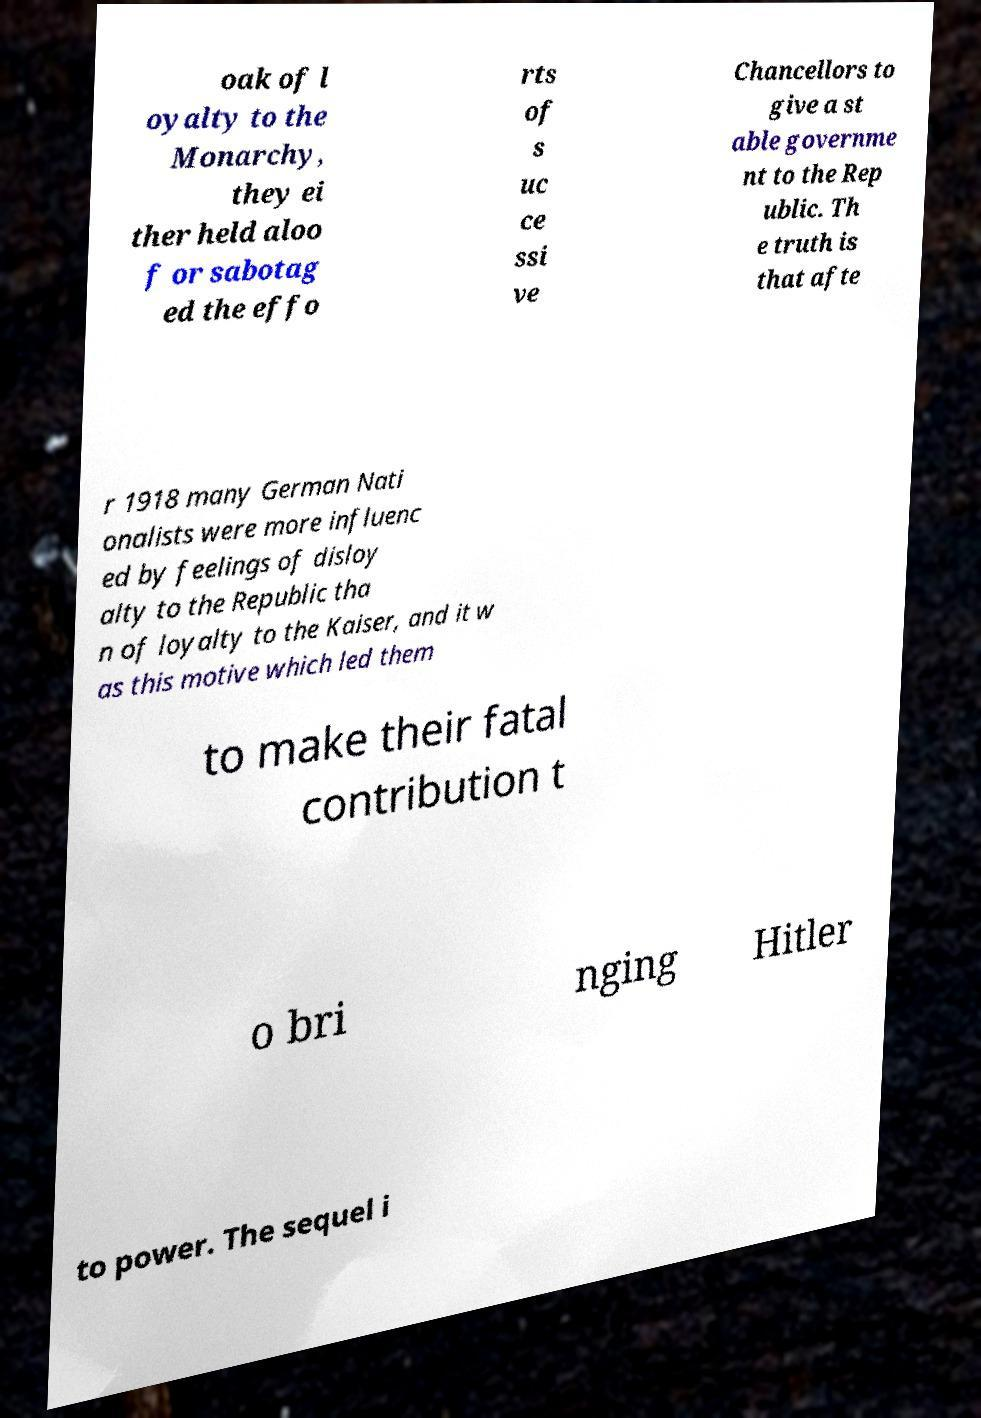Could you assist in decoding the text presented in this image and type it out clearly? oak of l oyalty to the Monarchy, they ei ther held aloo f or sabotag ed the effo rts of s uc ce ssi ve Chancellors to give a st able governme nt to the Rep ublic. Th e truth is that afte r 1918 many German Nati onalists were more influenc ed by feelings of disloy alty to the Republic tha n of loyalty to the Kaiser, and it w as this motive which led them to make their fatal contribution t o bri nging Hitler to power. The sequel i 